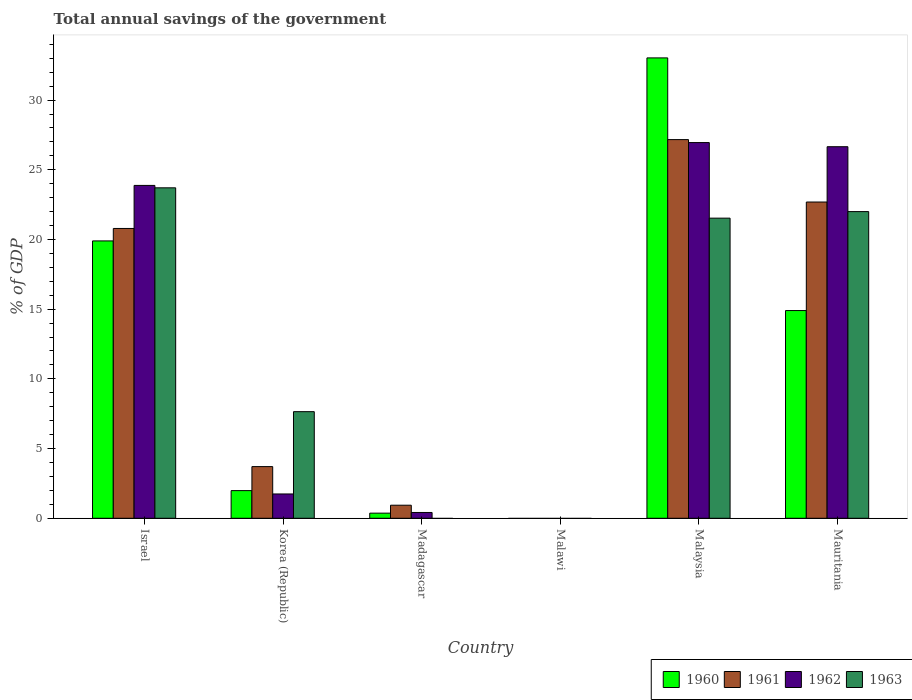How many different coloured bars are there?
Your answer should be compact. 4. Are the number of bars per tick equal to the number of legend labels?
Your answer should be compact. No. Are the number of bars on each tick of the X-axis equal?
Offer a very short reply. No. What is the label of the 3rd group of bars from the left?
Offer a very short reply. Madagascar. In how many cases, is the number of bars for a given country not equal to the number of legend labels?
Make the answer very short. 2. What is the total annual savings of the government in 1962 in Israel?
Offer a very short reply. 23.88. Across all countries, what is the maximum total annual savings of the government in 1962?
Offer a terse response. 26.95. In which country was the total annual savings of the government in 1960 maximum?
Make the answer very short. Malaysia. What is the total total annual savings of the government in 1961 in the graph?
Give a very brief answer. 75.28. What is the difference between the total annual savings of the government in 1962 in Korea (Republic) and that in Malaysia?
Offer a terse response. -25.21. What is the difference between the total annual savings of the government in 1963 in Madagascar and the total annual savings of the government in 1960 in Mauritania?
Provide a short and direct response. -14.9. What is the average total annual savings of the government in 1961 per country?
Your answer should be compact. 12.55. What is the difference between the total annual savings of the government of/in 1961 and total annual savings of the government of/in 1963 in Korea (Republic)?
Keep it short and to the point. -3.94. In how many countries, is the total annual savings of the government in 1961 greater than 13 %?
Ensure brevity in your answer.  3. What is the ratio of the total annual savings of the government in 1962 in Malaysia to that in Mauritania?
Provide a short and direct response. 1.01. Is the difference between the total annual savings of the government in 1961 in Korea (Republic) and Mauritania greater than the difference between the total annual savings of the government in 1963 in Korea (Republic) and Mauritania?
Offer a terse response. No. What is the difference between the highest and the second highest total annual savings of the government in 1962?
Offer a terse response. 0.3. What is the difference between the highest and the lowest total annual savings of the government in 1962?
Provide a succinct answer. 26.95. Is it the case that in every country, the sum of the total annual savings of the government in 1962 and total annual savings of the government in 1963 is greater than the sum of total annual savings of the government in 1961 and total annual savings of the government in 1960?
Offer a terse response. No. What is the difference between two consecutive major ticks on the Y-axis?
Your answer should be compact. 5. Does the graph contain grids?
Your answer should be compact. No. Where does the legend appear in the graph?
Give a very brief answer. Bottom right. How many legend labels are there?
Give a very brief answer. 4. What is the title of the graph?
Make the answer very short. Total annual savings of the government. Does "1962" appear as one of the legend labels in the graph?
Provide a succinct answer. Yes. What is the label or title of the Y-axis?
Offer a very short reply. % of GDP. What is the % of GDP of 1960 in Israel?
Your answer should be compact. 19.9. What is the % of GDP in 1961 in Israel?
Give a very brief answer. 20.79. What is the % of GDP in 1962 in Israel?
Make the answer very short. 23.88. What is the % of GDP in 1963 in Israel?
Provide a succinct answer. 23.71. What is the % of GDP in 1960 in Korea (Republic)?
Offer a very short reply. 1.98. What is the % of GDP of 1961 in Korea (Republic)?
Your response must be concise. 3.71. What is the % of GDP in 1962 in Korea (Republic)?
Keep it short and to the point. 1.74. What is the % of GDP of 1963 in Korea (Republic)?
Your response must be concise. 7.65. What is the % of GDP in 1960 in Madagascar?
Your answer should be very brief. 0.37. What is the % of GDP of 1961 in Madagascar?
Ensure brevity in your answer.  0.94. What is the % of GDP in 1962 in Madagascar?
Keep it short and to the point. 0.42. What is the % of GDP of 1963 in Madagascar?
Your answer should be very brief. 0. What is the % of GDP in 1960 in Malawi?
Your answer should be very brief. 0. What is the % of GDP in 1960 in Malaysia?
Give a very brief answer. 33.03. What is the % of GDP in 1961 in Malaysia?
Keep it short and to the point. 27.16. What is the % of GDP in 1962 in Malaysia?
Provide a short and direct response. 26.95. What is the % of GDP of 1963 in Malaysia?
Ensure brevity in your answer.  21.53. What is the % of GDP of 1960 in Mauritania?
Give a very brief answer. 14.9. What is the % of GDP of 1961 in Mauritania?
Provide a succinct answer. 22.69. What is the % of GDP of 1962 in Mauritania?
Offer a very short reply. 26.65. What is the % of GDP of 1963 in Mauritania?
Provide a succinct answer. 22. Across all countries, what is the maximum % of GDP in 1960?
Offer a terse response. 33.03. Across all countries, what is the maximum % of GDP in 1961?
Your answer should be compact. 27.16. Across all countries, what is the maximum % of GDP in 1962?
Offer a very short reply. 26.95. Across all countries, what is the maximum % of GDP of 1963?
Provide a succinct answer. 23.71. Across all countries, what is the minimum % of GDP in 1961?
Offer a very short reply. 0. Across all countries, what is the minimum % of GDP of 1962?
Keep it short and to the point. 0. Across all countries, what is the minimum % of GDP in 1963?
Your response must be concise. 0. What is the total % of GDP of 1960 in the graph?
Keep it short and to the point. 70.17. What is the total % of GDP of 1961 in the graph?
Your response must be concise. 75.28. What is the total % of GDP of 1962 in the graph?
Provide a succinct answer. 79.64. What is the total % of GDP in 1963 in the graph?
Offer a terse response. 74.88. What is the difference between the % of GDP of 1960 in Israel and that in Korea (Republic)?
Your answer should be very brief. 17.91. What is the difference between the % of GDP of 1961 in Israel and that in Korea (Republic)?
Your answer should be compact. 17.08. What is the difference between the % of GDP of 1962 in Israel and that in Korea (Republic)?
Keep it short and to the point. 22.13. What is the difference between the % of GDP in 1963 in Israel and that in Korea (Republic)?
Your answer should be very brief. 16.06. What is the difference between the % of GDP of 1960 in Israel and that in Madagascar?
Offer a very short reply. 19.53. What is the difference between the % of GDP in 1961 in Israel and that in Madagascar?
Give a very brief answer. 19.85. What is the difference between the % of GDP in 1962 in Israel and that in Madagascar?
Offer a terse response. 23.46. What is the difference between the % of GDP in 1960 in Israel and that in Malaysia?
Provide a succinct answer. -13.13. What is the difference between the % of GDP of 1961 in Israel and that in Malaysia?
Your answer should be compact. -6.37. What is the difference between the % of GDP of 1962 in Israel and that in Malaysia?
Offer a terse response. -3.07. What is the difference between the % of GDP in 1963 in Israel and that in Malaysia?
Keep it short and to the point. 2.18. What is the difference between the % of GDP of 1960 in Israel and that in Mauritania?
Provide a short and direct response. 5. What is the difference between the % of GDP in 1961 in Israel and that in Mauritania?
Your answer should be compact. -1.9. What is the difference between the % of GDP in 1962 in Israel and that in Mauritania?
Give a very brief answer. -2.78. What is the difference between the % of GDP in 1963 in Israel and that in Mauritania?
Provide a succinct answer. 1.71. What is the difference between the % of GDP in 1960 in Korea (Republic) and that in Madagascar?
Your response must be concise. 1.62. What is the difference between the % of GDP in 1961 in Korea (Republic) and that in Madagascar?
Your response must be concise. 2.77. What is the difference between the % of GDP of 1962 in Korea (Republic) and that in Madagascar?
Offer a very short reply. 1.33. What is the difference between the % of GDP of 1960 in Korea (Republic) and that in Malaysia?
Provide a short and direct response. -31.04. What is the difference between the % of GDP in 1961 in Korea (Republic) and that in Malaysia?
Offer a very short reply. -23.46. What is the difference between the % of GDP of 1962 in Korea (Republic) and that in Malaysia?
Offer a very short reply. -25.21. What is the difference between the % of GDP of 1963 in Korea (Republic) and that in Malaysia?
Your answer should be very brief. -13.88. What is the difference between the % of GDP in 1960 in Korea (Republic) and that in Mauritania?
Your response must be concise. -12.92. What is the difference between the % of GDP in 1961 in Korea (Republic) and that in Mauritania?
Offer a terse response. -18.98. What is the difference between the % of GDP in 1962 in Korea (Republic) and that in Mauritania?
Provide a succinct answer. -24.91. What is the difference between the % of GDP of 1963 in Korea (Republic) and that in Mauritania?
Keep it short and to the point. -14.35. What is the difference between the % of GDP in 1960 in Madagascar and that in Malaysia?
Offer a very short reply. -32.66. What is the difference between the % of GDP of 1961 in Madagascar and that in Malaysia?
Your response must be concise. -26.23. What is the difference between the % of GDP in 1962 in Madagascar and that in Malaysia?
Give a very brief answer. -26.53. What is the difference between the % of GDP of 1960 in Madagascar and that in Mauritania?
Offer a terse response. -14.53. What is the difference between the % of GDP of 1961 in Madagascar and that in Mauritania?
Your answer should be very brief. -21.75. What is the difference between the % of GDP of 1962 in Madagascar and that in Mauritania?
Make the answer very short. -26.24. What is the difference between the % of GDP in 1960 in Malaysia and that in Mauritania?
Provide a succinct answer. 18.13. What is the difference between the % of GDP in 1961 in Malaysia and that in Mauritania?
Your response must be concise. 4.48. What is the difference between the % of GDP in 1962 in Malaysia and that in Mauritania?
Provide a short and direct response. 0.3. What is the difference between the % of GDP in 1963 in Malaysia and that in Mauritania?
Your answer should be very brief. -0.47. What is the difference between the % of GDP of 1960 in Israel and the % of GDP of 1961 in Korea (Republic)?
Your answer should be compact. 16.19. What is the difference between the % of GDP in 1960 in Israel and the % of GDP in 1962 in Korea (Republic)?
Offer a very short reply. 18.15. What is the difference between the % of GDP in 1960 in Israel and the % of GDP in 1963 in Korea (Republic)?
Provide a succinct answer. 12.25. What is the difference between the % of GDP of 1961 in Israel and the % of GDP of 1962 in Korea (Republic)?
Offer a very short reply. 19.05. What is the difference between the % of GDP of 1961 in Israel and the % of GDP of 1963 in Korea (Republic)?
Offer a terse response. 13.14. What is the difference between the % of GDP in 1962 in Israel and the % of GDP in 1963 in Korea (Republic)?
Make the answer very short. 16.23. What is the difference between the % of GDP in 1960 in Israel and the % of GDP in 1961 in Madagascar?
Provide a succinct answer. 18.96. What is the difference between the % of GDP in 1960 in Israel and the % of GDP in 1962 in Madagascar?
Provide a succinct answer. 19.48. What is the difference between the % of GDP of 1961 in Israel and the % of GDP of 1962 in Madagascar?
Your answer should be compact. 20.37. What is the difference between the % of GDP in 1960 in Israel and the % of GDP in 1961 in Malaysia?
Provide a succinct answer. -7.27. What is the difference between the % of GDP in 1960 in Israel and the % of GDP in 1962 in Malaysia?
Offer a terse response. -7.05. What is the difference between the % of GDP in 1960 in Israel and the % of GDP in 1963 in Malaysia?
Your response must be concise. -1.63. What is the difference between the % of GDP in 1961 in Israel and the % of GDP in 1962 in Malaysia?
Offer a terse response. -6.16. What is the difference between the % of GDP of 1961 in Israel and the % of GDP of 1963 in Malaysia?
Ensure brevity in your answer.  -0.74. What is the difference between the % of GDP of 1962 in Israel and the % of GDP of 1963 in Malaysia?
Make the answer very short. 2.35. What is the difference between the % of GDP of 1960 in Israel and the % of GDP of 1961 in Mauritania?
Offer a very short reply. -2.79. What is the difference between the % of GDP in 1960 in Israel and the % of GDP in 1962 in Mauritania?
Ensure brevity in your answer.  -6.76. What is the difference between the % of GDP of 1960 in Israel and the % of GDP of 1963 in Mauritania?
Keep it short and to the point. -2.1. What is the difference between the % of GDP in 1961 in Israel and the % of GDP in 1962 in Mauritania?
Keep it short and to the point. -5.86. What is the difference between the % of GDP of 1961 in Israel and the % of GDP of 1963 in Mauritania?
Keep it short and to the point. -1.21. What is the difference between the % of GDP of 1962 in Israel and the % of GDP of 1963 in Mauritania?
Give a very brief answer. 1.88. What is the difference between the % of GDP of 1960 in Korea (Republic) and the % of GDP of 1961 in Madagascar?
Give a very brief answer. 1.05. What is the difference between the % of GDP in 1960 in Korea (Republic) and the % of GDP in 1962 in Madagascar?
Provide a succinct answer. 1.57. What is the difference between the % of GDP of 1961 in Korea (Republic) and the % of GDP of 1962 in Madagascar?
Your answer should be compact. 3.29. What is the difference between the % of GDP of 1960 in Korea (Republic) and the % of GDP of 1961 in Malaysia?
Give a very brief answer. -25.18. What is the difference between the % of GDP in 1960 in Korea (Republic) and the % of GDP in 1962 in Malaysia?
Offer a terse response. -24.97. What is the difference between the % of GDP of 1960 in Korea (Republic) and the % of GDP of 1963 in Malaysia?
Give a very brief answer. -19.55. What is the difference between the % of GDP of 1961 in Korea (Republic) and the % of GDP of 1962 in Malaysia?
Keep it short and to the point. -23.24. What is the difference between the % of GDP in 1961 in Korea (Republic) and the % of GDP in 1963 in Malaysia?
Offer a very short reply. -17.82. What is the difference between the % of GDP of 1962 in Korea (Republic) and the % of GDP of 1963 in Malaysia?
Your answer should be very brief. -19.79. What is the difference between the % of GDP of 1960 in Korea (Republic) and the % of GDP of 1961 in Mauritania?
Offer a very short reply. -20.7. What is the difference between the % of GDP in 1960 in Korea (Republic) and the % of GDP in 1962 in Mauritania?
Your answer should be compact. -24.67. What is the difference between the % of GDP in 1960 in Korea (Republic) and the % of GDP in 1963 in Mauritania?
Ensure brevity in your answer.  -20.02. What is the difference between the % of GDP in 1961 in Korea (Republic) and the % of GDP in 1962 in Mauritania?
Provide a short and direct response. -22.95. What is the difference between the % of GDP in 1961 in Korea (Republic) and the % of GDP in 1963 in Mauritania?
Provide a short and direct response. -18.29. What is the difference between the % of GDP of 1962 in Korea (Republic) and the % of GDP of 1963 in Mauritania?
Offer a very short reply. -20.25. What is the difference between the % of GDP of 1960 in Madagascar and the % of GDP of 1961 in Malaysia?
Give a very brief answer. -26.8. What is the difference between the % of GDP in 1960 in Madagascar and the % of GDP in 1962 in Malaysia?
Your answer should be very brief. -26.58. What is the difference between the % of GDP of 1960 in Madagascar and the % of GDP of 1963 in Malaysia?
Offer a very short reply. -21.16. What is the difference between the % of GDP in 1961 in Madagascar and the % of GDP in 1962 in Malaysia?
Offer a very short reply. -26.01. What is the difference between the % of GDP of 1961 in Madagascar and the % of GDP of 1963 in Malaysia?
Keep it short and to the point. -20.59. What is the difference between the % of GDP of 1962 in Madagascar and the % of GDP of 1963 in Malaysia?
Provide a short and direct response. -21.11. What is the difference between the % of GDP in 1960 in Madagascar and the % of GDP in 1961 in Mauritania?
Provide a short and direct response. -22.32. What is the difference between the % of GDP of 1960 in Madagascar and the % of GDP of 1962 in Mauritania?
Provide a short and direct response. -26.29. What is the difference between the % of GDP of 1960 in Madagascar and the % of GDP of 1963 in Mauritania?
Provide a short and direct response. -21.63. What is the difference between the % of GDP in 1961 in Madagascar and the % of GDP in 1962 in Mauritania?
Provide a short and direct response. -25.72. What is the difference between the % of GDP of 1961 in Madagascar and the % of GDP of 1963 in Mauritania?
Offer a very short reply. -21.06. What is the difference between the % of GDP in 1962 in Madagascar and the % of GDP in 1963 in Mauritania?
Provide a succinct answer. -21.58. What is the difference between the % of GDP in 1960 in Malaysia and the % of GDP in 1961 in Mauritania?
Your answer should be very brief. 10.34. What is the difference between the % of GDP in 1960 in Malaysia and the % of GDP in 1962 in Mauritania?
Make the answer very short. 6.37. What is the difference between the % of GDP of 1960 in Malaysia and the % of GDP of 1963 in Mauritania?
Give a very brief answer. 11.03. What is the difference between the % of GDP of 1961 in Malaysia and the % of GDP of 1962 in Mauritania?
Your response must be concise. 0.51. What is the difference between the % of GDP of 1961 in Malaysia and the % of GDP of 1963 in Mauritania?
Your answer should be very brief. 5.17. What is the difference between the % of GDP in 1962 in Malaysia and the % of GDP in 1963 in Mauritania?
Ensure brevity in your answer.  4.95. What is the average % of GDP in 1960 per country?
Your answer should be compact. 11.7. What is the average % of GDP of 1961 per country?
Provide a short and direct response. 12.55. What is the average % of GDP in 1962 per country?
Offer a terse response. 13.27. What is the average % of GDP of 1963 per country?
Provide a succinct answer. 12.48. What is the difference between the % of GDP in 1960 and % of GDP in 1961 in Israel?
Provide a short and direct response. -0.89. What is the difference between the % of GDP of 1960 and % of GDP of 1962 in Israel?
Provide a short and direct response. -3.98. What is the difference between the % of GDP in 1960 and % of GDP in 1963 in Israel?
Offer a very short reply. -3.81. What is the difference between the % of GDP in 1961 and % of GDP in 1962 in Israel?
Ensure brevity in your answer.  -3.09. What is the difference between the % of GDP of 1961 and % of GDP of 1963 in Israel?
Your response must be concise. -2.91. What is the difference between the % of GDP of 1962 and % of GDP of 1963 in Israel?
Provide a succinct answer. 0.17. What is the difference between the % of GDP of 1960 and % of GDP of 1961 in Korea (Republic)?
Offer a terse response. -1.72. What is the difference between the % of GDP of 1960 and % of GDP of 1962 in Korea (Republic)?
Offer a terse response. 0.24. What is the difference between the % of GDP of 1960 and % of GDP of 1963 in Korea (Republic)?
Keep it short and to the point. -5.66. What is the difference between the % of GDP of 1961 and % of GDP of 1962 in Korea (Republic)?
Make the answer very short. 1.96. What is the difference between the % of GDP of 1961 and % of GDP of 1963 in Korea (Republic)?
Ensure brevity in your answer.  -3.94. What is the difference between the % of GDP of 1962 and % of GDP of 1963 in Korea (Republic)?
Give a very brief answer. -5.9. What is the difference between the % of GDP of 1960 and % of GDP of 1961 in Madagascar?
Keep it short and to the point. -0.57. What is the difference between the % of GDP of 1960 and % of GDP of 1962 in Madagascar?
Offer a very short reply. -0.05. What is the difference between the % of GDP in 1961 and % of GDP in 1962 in Madagascar?
Give a very brief answer. 0.52. What is the difference between the % of GDP of 1960 and % of GDP of 1961 in Malaysia?
Your response must be concise. 5.86. What is the difference between the % of GDP in 1960 and % of GDP in 1962 in Malaysia?
Give a very brief answer. 6.07. What is the difference between the % of GDP of 1960 and % of GDP of 1963 in Malaysia?
Keep it short and to the point. 11.5. What is the difference between the % of GDP of 1961 and % of GDP of 1962 in Malaysia?
Keep it short and to the point. 0.21. What is the difference between the % of GDP of 1961 and % of GDP of 1963 in Malaysia?
Keep it short and to the point. 5.63. What is the difference between the % of GDP of 1962 and % of GDP of 1963 in Malaysia?
Ensure brevity in your answer.  5.42. What is the difference between the % of GDP in 1960 and % of GDP in 1961 in Mauritania?
Provide a short and direct response. -7.79. What is the difference between the % of GDP in 1960 and % of GDP in 1962 in Mauritania?
Provide a short and direct response. -11.75. What is the difference between the % of GDP in 1960 and % of GDP in 1963 in Mauritania?
Make the answer very short. -7.1. What is the difference between the % of GDP in 1961 and % of GDP in 1962 in Mauritania?
Offer a terse response. -3.97. What is the difference between the % of GDP of 1961 and % of GDP of 1963 in Mauritania?
Provide a short and direct response. 0.69. What is the difference between the % of GDP of 1962 and % of GDP of 1963 in Mauritania?
Your response must be concise. 4.66. What is the ratio of the % of GDP of 1960 in Israel to that in Korea (Republic)?
Your answer should be compact. 10.03. What is the ratio of the % of GDP of 1961 in Israel to that in Korea (Republic)?
Give a very brief answer. 5.61. What is the ratio of the % of GDP of 1962 in Israel to that in Korea (Republic)?
Offer a terse response. 13.69. What is the ratio of the % of GDP of 1963 in Israel to that in Korea (Republic)?
Provide a short and direct response. 3.1. What is the ratio of the % of GDP of 1960 in Israel to that in Madagascar?
Make the answer very short. 54.21. What is the ratio of the % of GDP in 1961 in Israel to that in Madagascar?
Ensure brevity in your answer.  22.19. What is the ratio of the % of GDP in 1962 in Israel to that in Madagascar?
Make the answer very short. 57.4. What is the ratio of the % of GDP in 1960 in Israel to that in Malaysia?
Offer a terse response. 0.6. What is the ratio of the % of GDP of 1961 in Israel to that in Malaysia?
Ensure brevity in your answer.  0.77. What is the ratio of the % of GDP of 1962 in Israel to that in Malaysia?
Offer a very short reply. 0.89. What is the ratio of the % of GDP of 1963 in Israel to that in Malaysia?
Your answer should be very brief. 1.1. What is the ratio of the % of GDP of 1960 in Israel to that in Mauritania?
Keep it short and to the point. 1.34. What is the ratio of the % of GDP in 1961 in Israel to that in Mauritania?
Offer a very short reply. 0.92. What is the ratio of the % of GDP in 1962 in Israel to that in Mauritania?
Provide a short and direct response. 0.9. What is the ratio of the % of GDP of 1963 in Israel to that in Mauritania?
Your answer should be compact. 1.08. What is the ratio of the % of GDP of 1960 in Korea (Republic) to that in Madagascar?
Provide a succinct answer. 5.4. What is the ratio of the % of GDP of 1961 in Korea (Republic) to that in Madagascar?
Your answer should be compact. 3.96. What is the ratio of the % of GDP in 1962 in Korea (Republic) to that in Madagascar?
Your answer should be very brief. 4.19. What is the ratio of the % of GDP of 1960 in Korea (Republic) to that in Malaysia?
Provide a short and direct response. 0.06. What is the ratio of the % of GDP in 1961 in Korea (Republic) to that in Malaysia?
Keep it short and to the point. 0.14. What is the ratio of the % of GDP in 1962 in Korea (Republic) to that in Malaysia?
Your answer should be compact. 0.06. What is the ratio of the % of GDP in 1963 in Korea (Republic) to that in Malaysia?
Your answer should be compact. 0.36. What is the ratio of the % of GDP of 1960 in Korea (Republic) to that in Mauritania?
Your response must be concise. 0.13. What is the ratio of the % of GDP in 1961 in Korea (Republic) to that in Mauritania?
Keep it short and to the point. 0.16. What is the ratio of the % of GDP in 1962 in Korea (Republic) to that in Mauritania?
Your answer should be compact. 0.07. What is the ratio of the % of GDP in 1963 in Korea (Republic) to that in Mauritania?
Keep it short and to the point. 0.35. What is the ratio of the % of GDP in 1960 in Madagascar to that in Malaysia?
Make the answer very short. 0.01. What is the ratio of the % of GDP of 1961 in Madagascar to that in Malaysia?
Keep it short and to the point. 0.03. What is the ratio of the % of GDP of 1962 in Madagascar to that in Malaysia?
Offer a terse response. 0.02. What is the ratio of the % of GDP in 1960 in Madagascar to that in Mauritania?
Make the answer very short. 0.02. What is the ratio of the % of GDP in 1961 in Madagascar to that in Mauritania?
Ensure brevity in your answer.  0.04. What is the ratio of the % of GDP in 1962 in Madagascar to that in Mauritania?
Keep it short and to the point. 0.02. What is the ratio of the % of GDP of 1960 in Malaysia to that in Mauritania?
Your answer should be compact. 2.22. What is the ratio of the % of GDP in 1961 in Malaysia to that in Mauritania?
Offer a terse response. 1.2. What is the ratio of the % of GDP in 1962 in Malaysia to that in Mauritania?
Offer a terse response. 1.01. What is the ratio of the % of GDP of 1963 in Malaysia to that in Mauritania?
Give a very brief answer. 0.98. What is the difference between the highest and the second highest % of GDP in 1960?
Your response must be concise. 13.13. What is the difference between the highest and the second highest % of GDP of 1961?
Provide a short and direct response. 4.48. What is the difference between the highest and the second highest % of GDP in 1962?
Make the answer very short. 0.3. What is the difference between the highest and the second highest % of GDP in 1963?
Provide a succinct answer. 1.71. What is the difference between the highest and the lowest % of GDP in 1960?
Your answer should be compact. 33.03. What is the difference between the highest and the lowest % of GDP of 1961?
Give a very brief answer. 27.16. What is the difference between the highest and the lowest % of GDP in 1962?
Give a very brief answer. 26.95. What is the difference between the highest and the lowest % of GDP of 1963?
Your response must be concise. 23.7. 